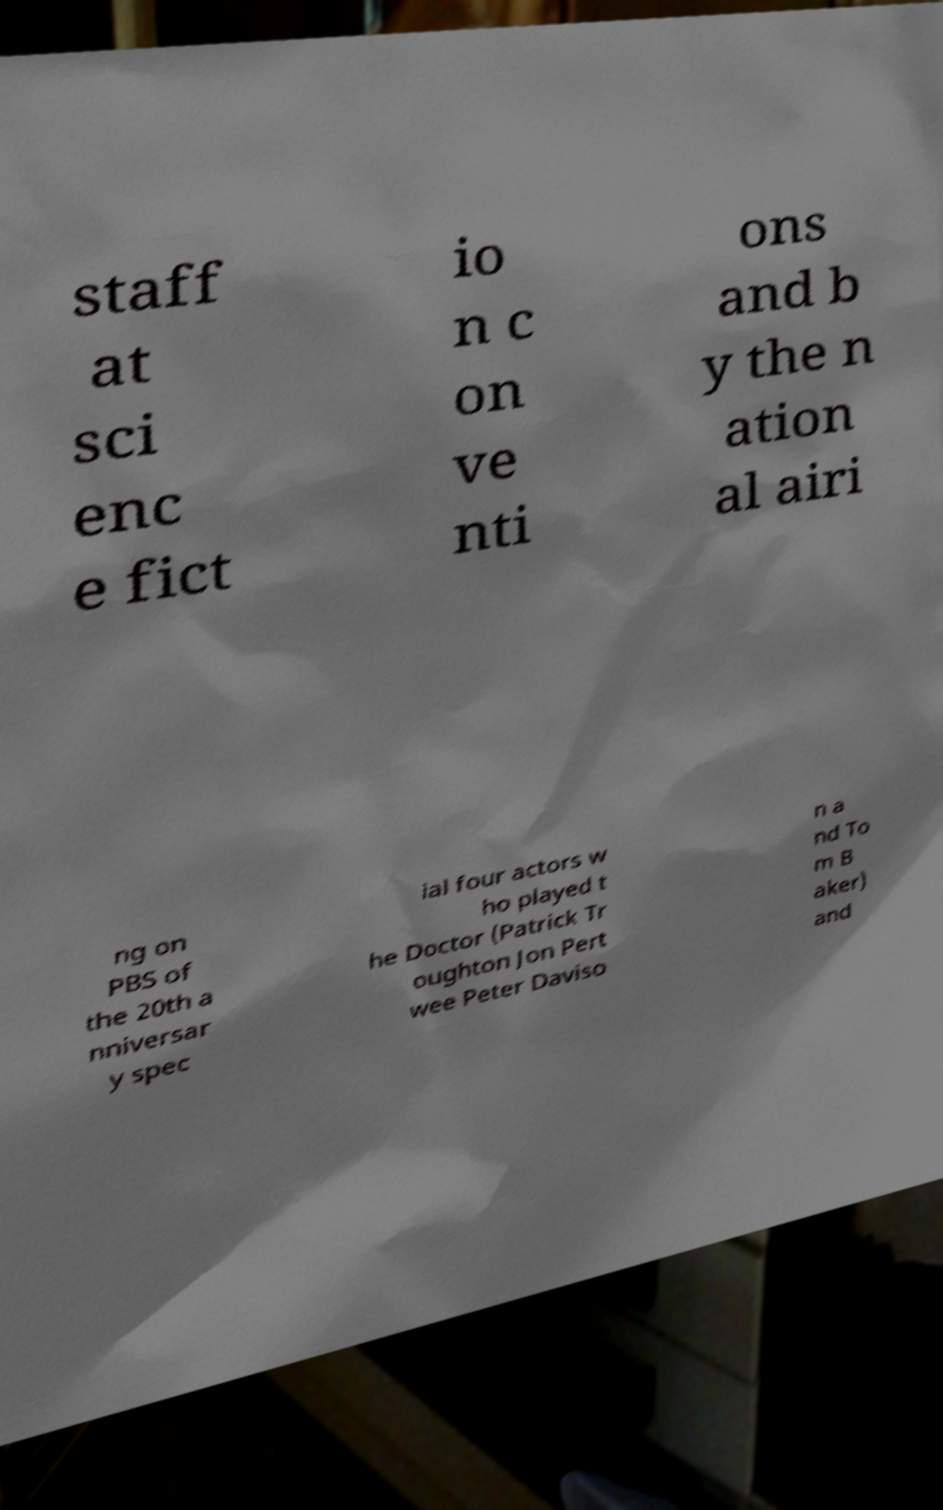What messages or text are displayed in this image? I need them in a readable, typed format. staff at sci enc e fict io n c on ve nti ons and b y the n ation al airi ng on PBS of the 20th a nniversar y spec ial four actors w ho played t he Doctor (Patrick Tr oughton Jon Pert wee Peter Daviso n a nd To m B aker) and 